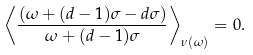<formula> <loc_0><loc_0><loc_500><loc_500>\left \langle \frac { ( \omega + ( d - 1 ) \sigma - d \sigma ) } { \omega + ( d - 1 ) \sigma } \right \rangle _ { \nu ( \omega ) } = 0 .</formula> 